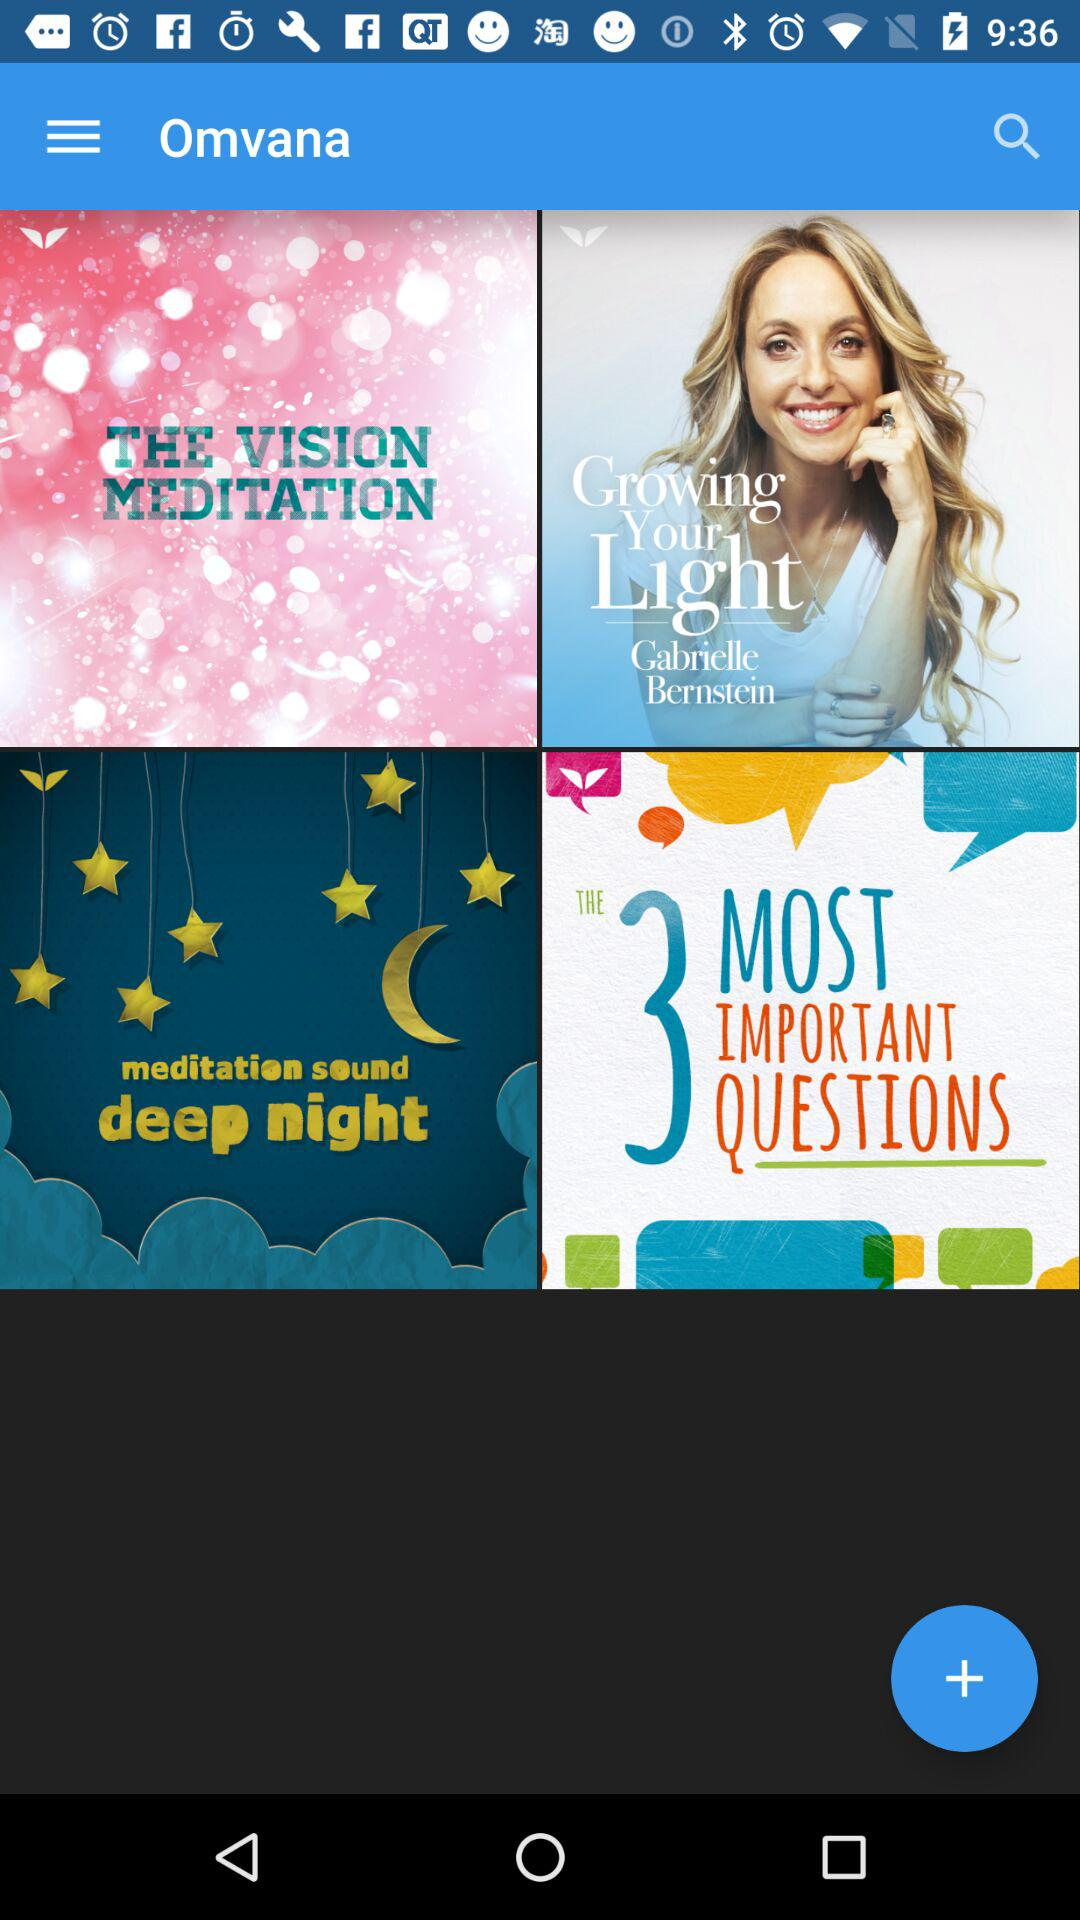How many images can be selected?
When the provided information is insufficient, respond with <no answer>. <no answer> 